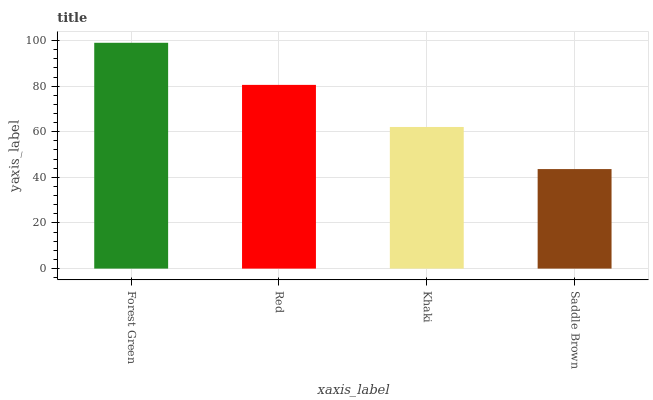Is Saddle Brown the minimum?
Answer yes or no. Yes. Is Forest Green the maximum?
Answer yes or no. Yes. Is Red the minimum?
Answer yes or no. No. Is Red the maximum?
Answer yes or no. No. Is Forest Green greater than Red?
Answer yes or no. Yes. Is Red less than Forest Green?
Answer yes or no. Yes. Is Red greater than Forest Green?
Answer yes or no. No. Is Forest Green less than Red?
Answer yes or no. No. Is Red the high median?
Answer yes or no. Yes. Is Khaki the low median?
Answer yes or no. Yes. Is Khaki the high median?
Answer yes or no. No. Is Saddle Brown the low median?
Answer yes or no. No. 